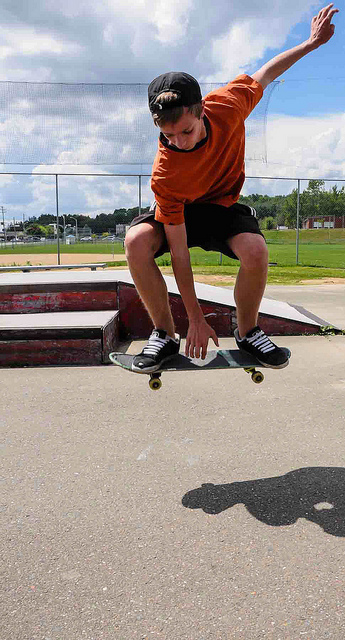Can you tell me about the setting of this photo? Certainly! The image shows a skatepark, characterized by the smooth concrete surfaces and obstacles designed for skating tricks like ramps and rails. This kind of environment is popular among skaters to practice and socialize. What's the importance of safety gear in this sport? Safety gear, including helmets, knee pads, elbow pads, and wrist guards, is crucial in skateboarding. It significantly reduces the risk of injuries, especially when learning new tricks or when skating on hard surfaces like concrete. 